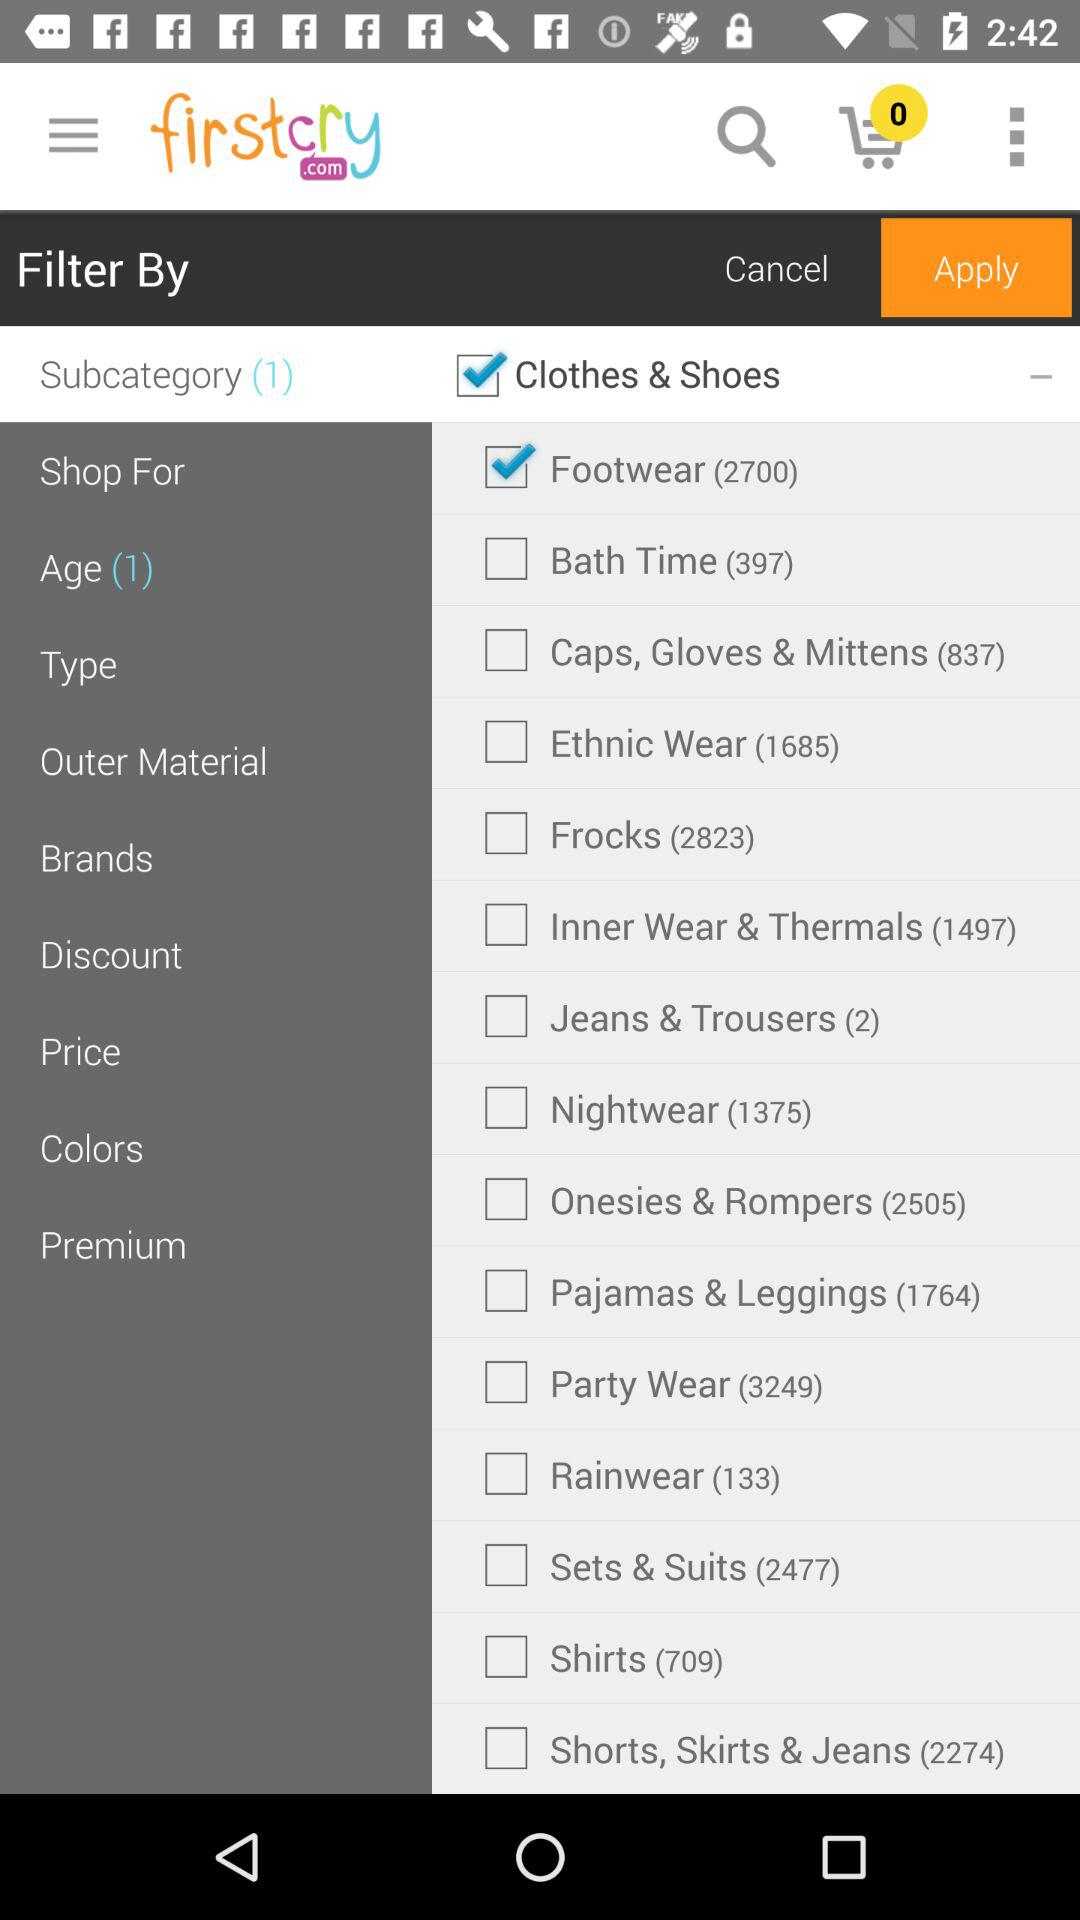Which item is selected in the menu? The selected item is "Subcategory". 